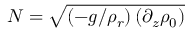<formula> <loc_0><loc_0><loc_500><loc_500>N = \sqrt { \left ( - g / \rho _ { r } \right ) \left ( \partial _ { z } \rho _ { 0 } \right ) }</formula> 